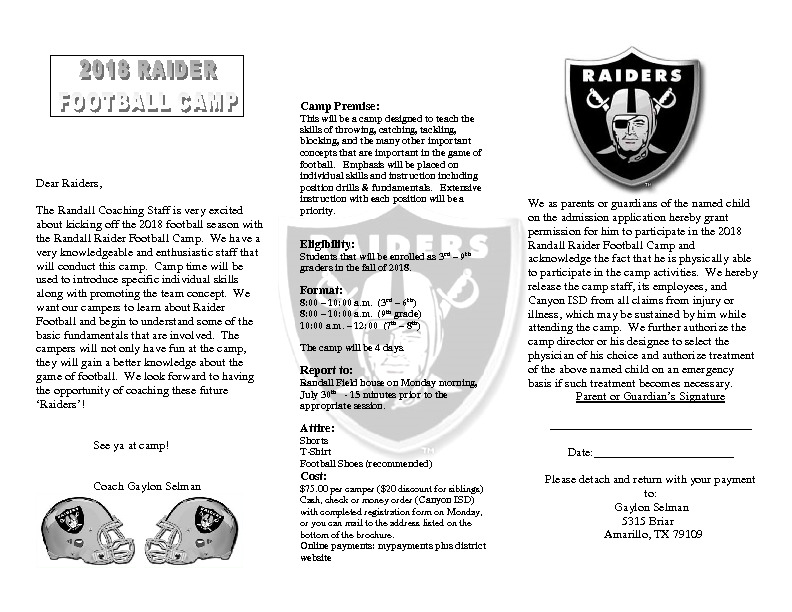If a child forgets to bring football shoes, what alternatives might the camp provide or suggest? If a child forgets to bring football shoes, the camp might suggest that the child wear any comfortable, closed-toe athletic shoes they have. These shoes would still provide some level of support and protection, although they may not offer the sharegpt4v/same benefits as specialized football shoes. The camp could also have a few spare pairs of football shoes available for temporary use, or it might encourage the child to participate in non-shoe-dependent drills and activities until suitable footwear is obtained. This ensures that all campers can still participate and enjoy the camp's activities, regardless of any forgotten items. What should parents consider when preparing their child for this camp? When preparing their child for this camp, parents should consider several important factors: 
1. **Attire**: Ensure the child has the recommended attire, including a T-shirt, shorts, and preferably football shoes. Comfortable, breathable clothing will keep the child cool and agile. 
2. **Hydration**: Pack a water bottle to keep the child hydrated, especially during intense activities. 
3. **Nourishment**: Ensure the child has a healthy breakfast before coming to camp and pack a nutritious snack if allowed. 
4. **Safety Gear**: While not explicitly listed, consider sending the child with basic safety gear like a mouthguard if they already own one. 
5. **Positive Attitude**: Encourage a positive mindset; remind the child that the focus is on learning and having fun, not just competition. 
6. **Drop-off and Pick-up**: Be on time for drop-off and pick-up to make sure the child has a smooth transition. All these preparations will help ensure the child has a positive and productive camp experience. 